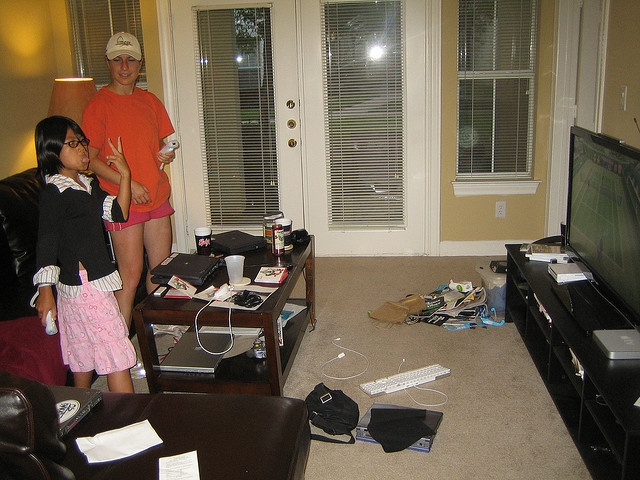Describe the objects in this image and their specific colors. I can see people in olive, black, lightpink, darkgray, and gray tones, people in olive and brown tones, tv in olive, black, darkgreen, and gray tones, couch in olive, black, maroon, gray, and darkgreen tones, and couch in olive, maroon, and purple tones in this image. 